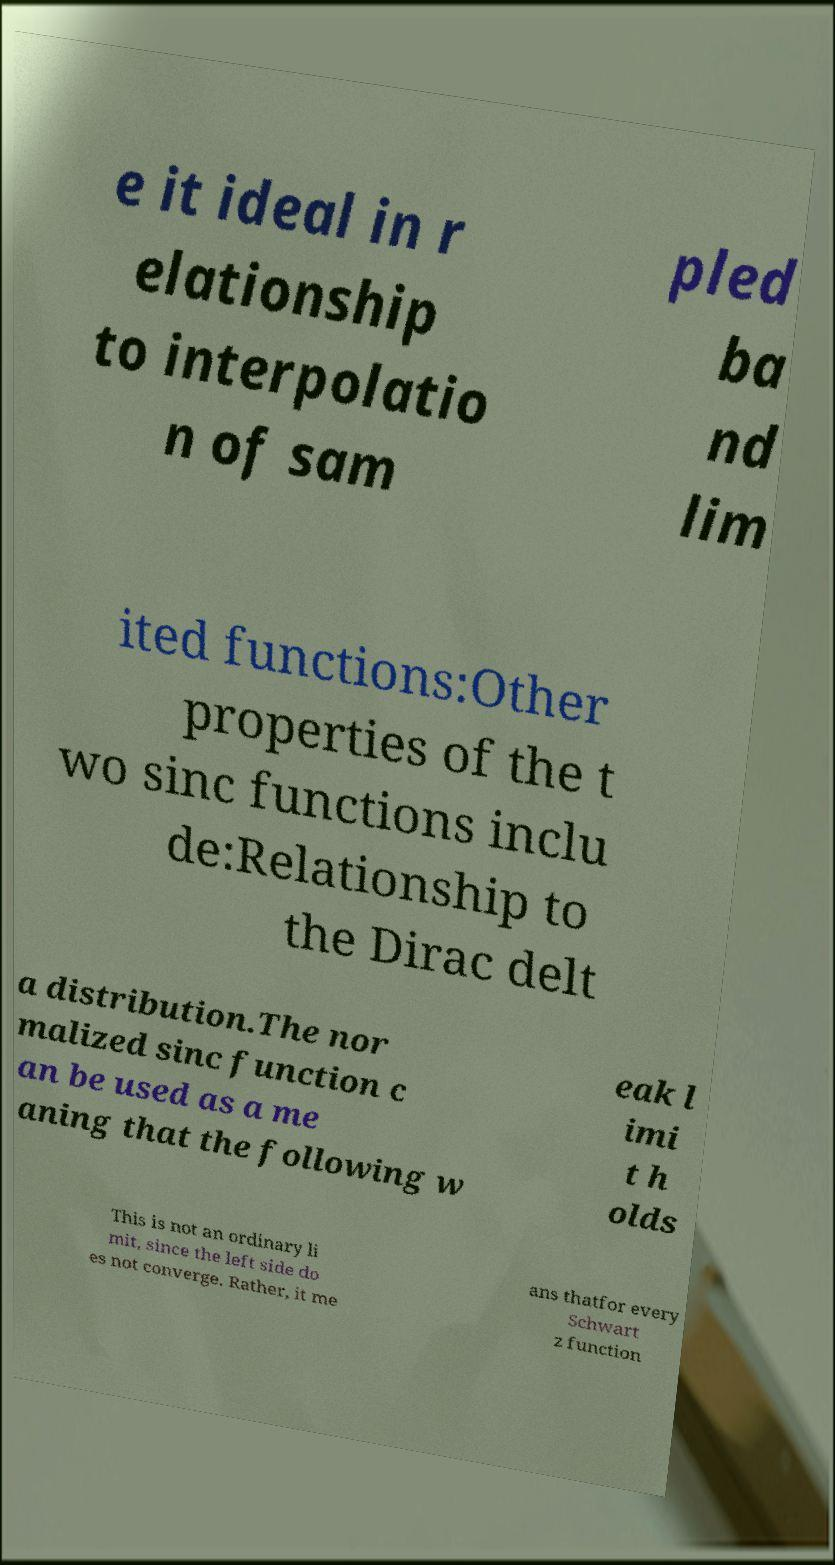Could you extract and type out the text from this image? e it ideal in r elationship to interpolatio n of sam pled ba nd lim ited functions:Other properties of the t wo sinc functions inclu de:Relationship to the Dirac delt a distribution.The nor malized sinc function c an be used as a me aning that the following w eak l imi t h olds This is not an ordinary li mit, since the left side do es not converge. Rather, it me ans thatfor every Schwart z function 